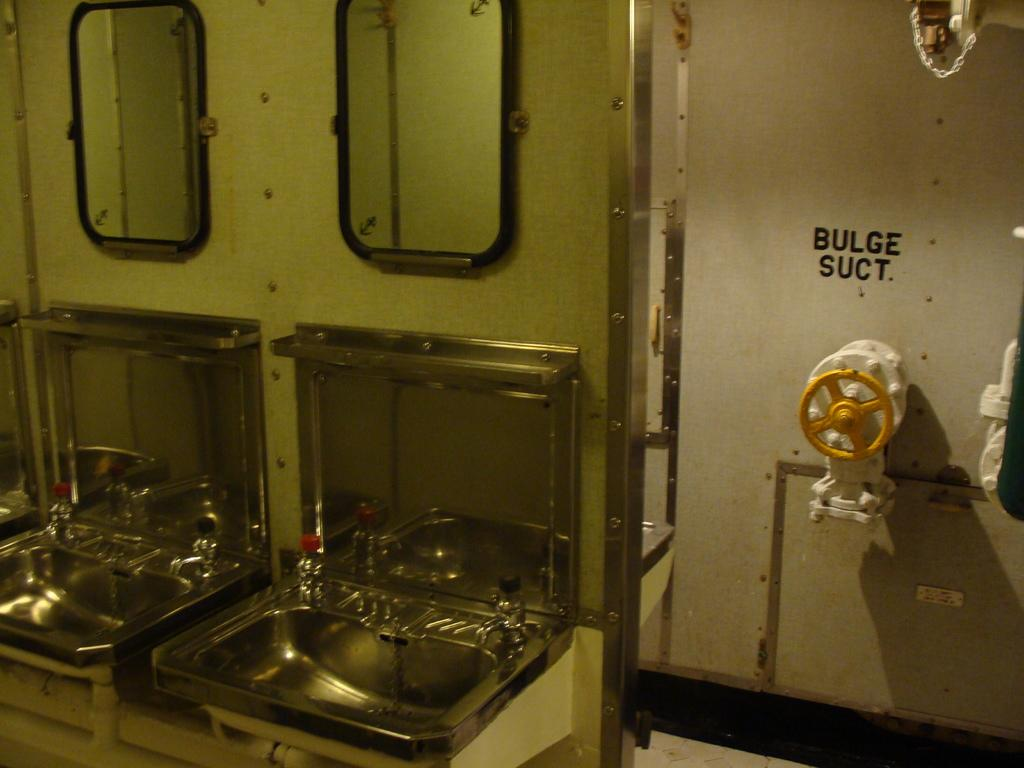<image>
Offer a succinct explanation of the picture presented. A yellow valve or control with a sign about it that says "Bulge Suct" 